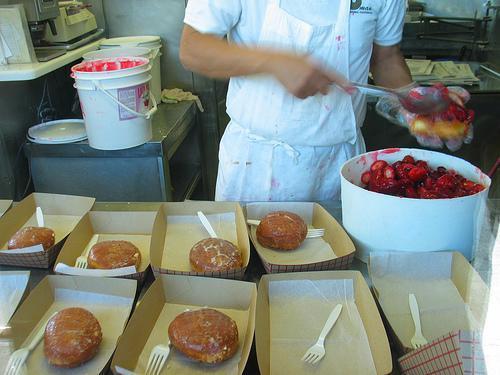How many people are pictured here?
Give a very brief answer. 1. 